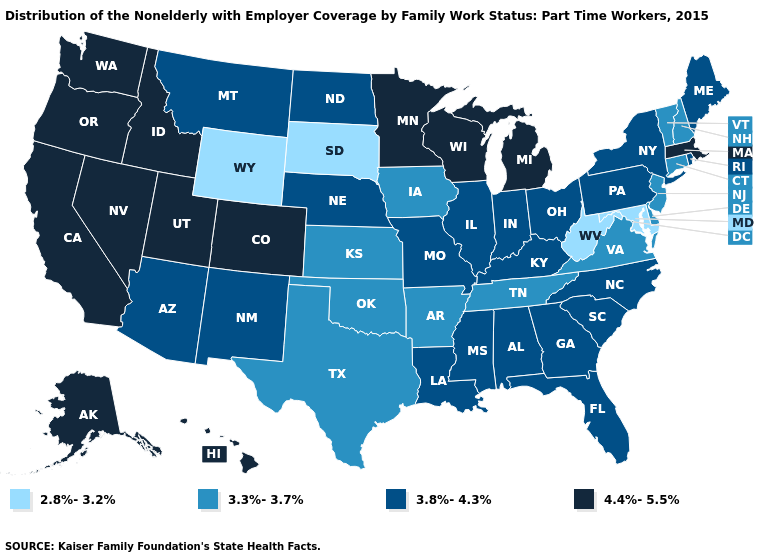Does the first symbol in the legend represent the smallest category?
Concise answer only. Yes. What is the value of Kentucky?
Keep it brief. 3.8%-4.3%. Name the states that have a value in the range 2.8%-3.2%?
Short answer required. Maryland, South Dakota, West Virginia, Wyoming. Name the states that have a value in the range 3.8%-4.3%?
Answer briefly. Alabama, Arizona, Florida, Georgia, Illinois, Indiana, Kentucky, Louisiana, Maine, Mississippi, Missouri, Montana, Nebraska, New Mexico, New York, North Carolina, North Dakota, Ohio, Pennsylvania, Rhode Island, South Carolina. Which states have the lowest value in the USA?
Short answer required. Maryland, South Dakota, West Virginia, Wyoming. What is the lowest value in states that border Missouri?
Short answer required. 3.3%-3.7%. What is the value of Utah?
Give a very brief answer. 4.4%-5.5%. Does Illinois have the same value as Nebraska?
Concise answer only. Yes. What is the value of California?
Be succinct. 4.4%-5.5%. What is the value of North Carolina?
Give a very brief answer. 3.8%-4.3%. Name the states that have a value in the range 3.3%-3.7%?
Concise answer only. Arkansas, Connecticut, Delaware, Iowa, Kansas, New Hampshire, New Jersey, Oklahoma, Tennessee, Texas, Vermont, Virginia. What is the highest value in the USA?
Answer briefly. 4.4%-5.5%. Does Alaska have the lowest value in the USA?
Answer briefly. No. What is the lowest value in states that border Arizona?
Quick response, please. 3.8%-4.3%. Among the states that border Minnesota , does North Dakota have the highest value?
Give a very brief answer. No. 